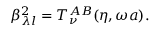Convert formula to latex. <formula><loc_0><loc_0><loc_500><loc_500>\beta _ { \lambda l } ^ { 2 } = T _ { \nu } ^ { A B } ( \eta , \omega a ) .</formula> 